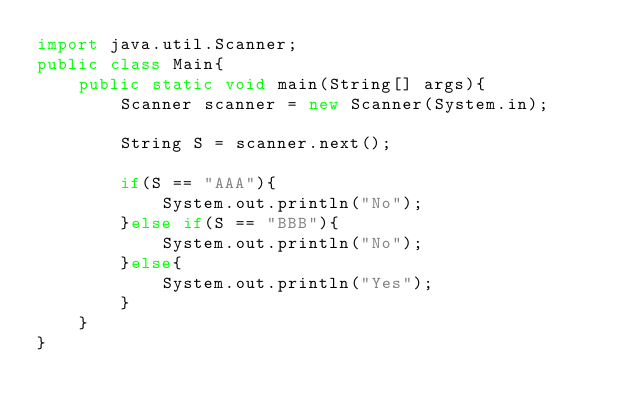<code> <loc_0><loc_0><loc_500><loc_500><_Java_>import java.util.Scanner;
public class Main{
    public static void main(String[] args){
        Scanner scanner = new Scanner(System.in);
 
        String S = scanner.next();
        
        if(S == "AAA"){
            System.out.println("No");
        }else if(S == "BBB"){
            System.out.println("No");
        }else{
            System.out.println("Yes");
        }
    }
}</code> 